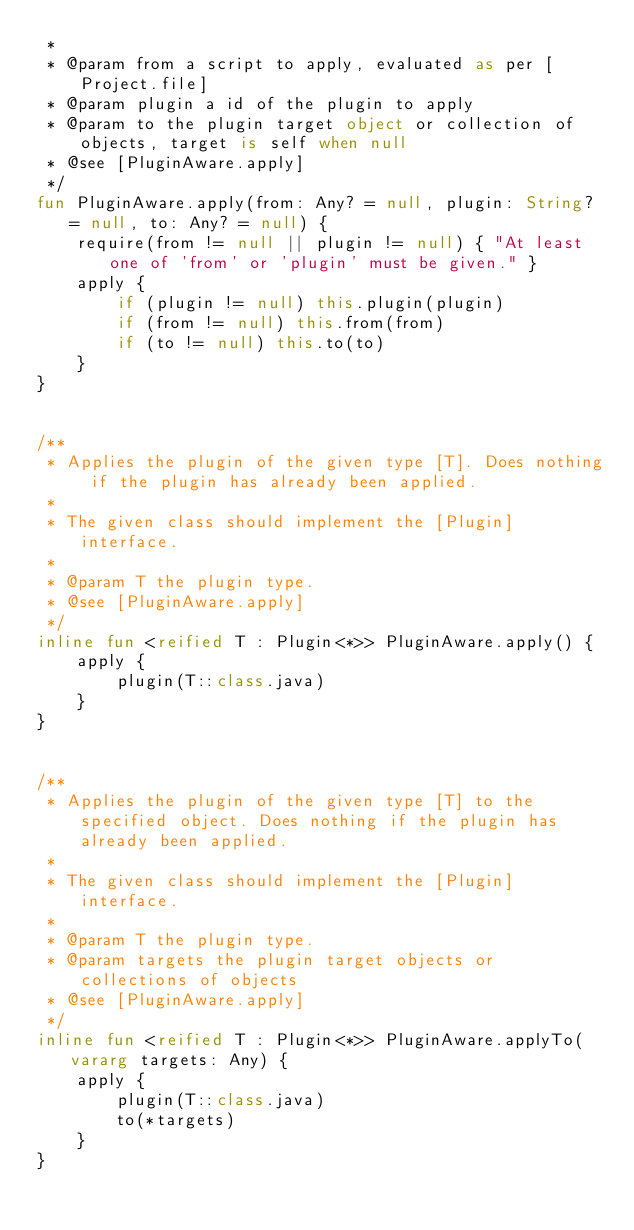Convert code to text. <code><loc_0><loc_0><loc_500><loc_500><_Kotlin_> *
 * @param from a script to apply, evaluated as per [Project.file]
 * @param plugin a id of the plugin to apply
 * @param to the plugin target object or collection of objects, target is self when null
 * @see [PluginAware.apply]
 */
fun PluginAware.apply(from: Any? = null, plugin: String? = null, to: Any? = null) {
    require(from != null || plugin != null) { "At least one of 'from' or 'plugin' must be given." }
    apply {
        if (plugin != null) this.plugin(plugin)
        if (from != null) this.from(from)
        if (to != null) this.to(to)
    }
}


/**
 * Applies the plugin of the given type [T]. Does nothing if the plugin has already been applied.
 *
 * The given class should implement the [Plugin] interface.
 *
 * @param T the plugin type.
 * @see [PluginAware.apply]
 */
inline fun <reified T : Plugin<*>> PluginAware.apply() {
    apply {
        plugin(T::class.java)
    }
}


/**
 * Applies the plugin of the given type [T] to the specified object. Does nothing if the plugin has already been applied.
 *
 * The given class should implement the [Plugin] interface.
 *
 * @param T the plugin type.
 * @param targets the plugin target objects or collections of objects
 * @see [PluginAware.apply]
 */
inline fun <reified T : Plugin<*>> PluginAware.applyTo(vararg targets: Any) {
    apply {
        plugin(T::class.java)
        to(*targets)
    }
}
</code> 